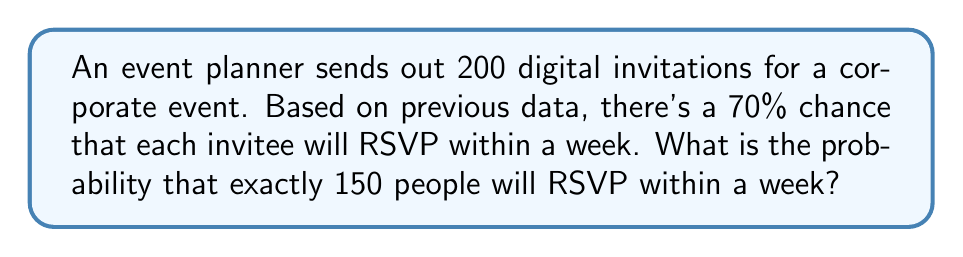Can you solve this math problem? To solve this problem, we'll use the binomial probability distribution, as we have a fixed number of independent trials (invitations) with two possible outcomes for each (RSVP within a week or not).

Let's break it down step-by-step:

1. Identify the parameters:
   - $n$ = 200 (total number of invitations)
   - $k$ = 150 (desired number of RSVPs)
   - $p$ = 0.70 (probability of an RSVP within a week)
   - $q$ = 1 - $p$ = 0.30 (probability of not RSVP-ing within a week)

2. Use the binomial probability formula:

   $$P(X = k) = \binom{n}{k} p^k q^{n-k}$$

3. Calculate the binomial coefficient:

   $$\binom{200}{150} = \frac{200!}{150!(200-150)!} = \frac{200!}{150!50!}$$

4. Substitute all values into the formula:

   $$P(X = 150) = \binom{200}{150} (0.70)^{150} (0.30)^{50}$$

5. Use a calculator or computer to evaluate this expression:

   $$P(X = 150) \approx 0.0399$$

Therefore, the probability of receiving exactly 150 RSVPs within a week is approximately 0.0399 or 3.99%.
Answer: $0.0399$ or $3.99\%$ 